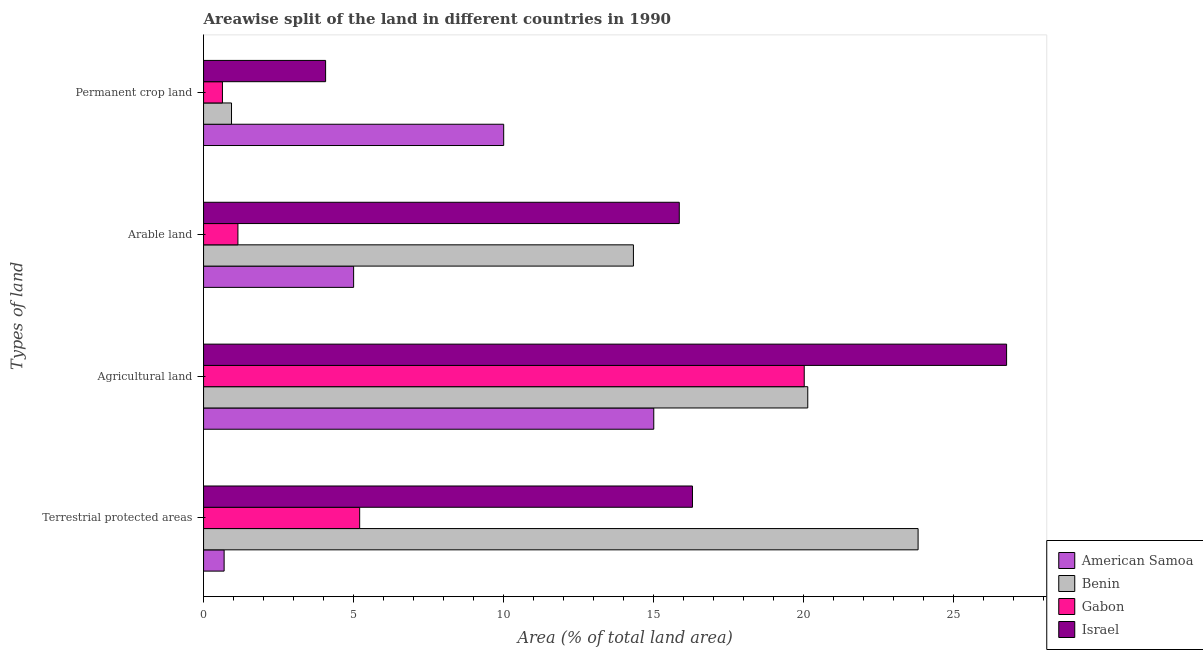How many groups of bars are there?
Your response must be concise. 4. Are the number of bars per tick equal to the number of legend labels?
Your response must be concise. Yes. Are the number of bars on each tick of the Y-axis equal?
Keep it short and to the point. Yes. What is the label of the 1st group of bars from the top?
Provide a short and direct response. Permanent crop land. What is the percentage of area under arable land in Israel?
Your answer should be very brief. 15.85. Across all countries, what is the maximum percentage of area under agricultural land?
Give a very brief answer. 26.76. Across all countries, what is the minimum percentage of area under arable land?
Your response must be concise. 1.14. In which country was the percentage of area under arable land maximum?
Provide a short and direct response. Israel. In which country was the percentage of land under terrestrial protection minimum?
Provide a succinct answer. American Samoa. What is the total percentage of area under permanent crop land in the graph?
Ensure brevity in your answer.  15.63. What is the difference between the percentage of area under agricultural land in Gabon and that in Benin?
Ensure brevity in your answer.  -0.12. What is the difference between the percentage of area under arable land in Benin and the percentage of land under terrestrial protection in Gabon?
Your answer should be compact. 9.12. What is the average percentage of land under terrestrial protection per country?
Offer a terse response. 11.5. What is the difference between the percentage of area under agricultural land and percentage of area under arable land in American Samoa?
Your answer should be very brief. 10. In how many countries, is the percentage of area under agricultural land greater than 6 %?
Your answer should be very brief. 4. What is the ratio of the percentage of area under arable land in Israel to that in Gabon?
Offer a terse response. 13.84. Is the difference between the percentage of land under terrestrial protection in Benin and American Samoa greater than the difference between the percentage of area under permanent crop land in Benin and American Samoa?
Make the answer very short. Yes. What is the difference between the highest and the second highest percentage of area under agricultural land?
Provide a succinct answer. 6.62. What is the difference between the highest and the lowest percentage of area under agricultural land?
Provide a short and direct response. 11.76. Is it the case that in every country, the sum of the percentage of land under terrestrial protection and percentage of area under permanent crop land is greater than the sum of percentage of area under agricultural land and percentage of area under arable land?
Provide a succinct answer. No. What does the 3rd bar from the top in Agricultural land represents?
Provide a short and direct response. Benin. What does the 1st bar from the bottom in Agricultural land represents?
Your response must be concise. American Samoa. Is it the case that in every country, the sum of the percentage of land under terrestrial protection and percentage of area under agricultural land is greater than the percentage of area under arable land?
Give a very brief answer. Yes. Are the values on the major ticks of X-axis written in scientific E-notation?
Give a very brief answer. No. Where does the legend appear in the graph?
Provide a succinct answer. Bottom right. How many legend labels are there?
Provide a succinct answer. 4. What is the title of the graph?
Your answer should be compact. Areawise split of the land in different countries in 1990. Does "East Asia (developing only)" appear as one of the legend labels in the graph?
Make the answer very short. No. What is the label or title of the X-axis?
Offer a terse response. Area (% of total land area). What is the label or title of the Y-axis?
Provide a succinct answer. Types of land. What is the Area (% of total land area) of American Samoa in Terrestrial protected areas?
Your answer should be compact. 0.69. What is the Area (% of total land area) in Benin in Terrestrial protected areas?
Keep it short and to the point. 23.81. What is the Area (% of total land area) of Gabon in Terrestrial protected areas?
Make the answer very short. 5.2. What is the Area (% of total land area) of Israel in Terrestrial protected areas?
Provide a short and direct response. 16.29. What is the Area (% of total land area) in Benin in Agricultural land?
Keep it short and to the point. 20.13. What is the Area (% of total land area) in Gabon in Agricultural land?
Give a very brief answer. 20.01. What is the Area (% of total land area) in Israel in Agricultural land?
Make the answer very short. 26.76. What is the Area (% of total land area) of American Samoa in Arable land?
Keep it short and to the point. 5. What is the Area (% of total land area) in Benin in Arable land?
Keep it short and to the point. 14.32. What is the Area (% of total land area) in Gabon in Arable land?
Ensure brevity in your answer.  1.14. What is the Area (% of total land area) of Israel in Arable land?
Your answer should be very brief. 15.85. What is the Area (% of total land area) of American Samoa in Permanent crop land?
Your answer should be compact. 10. What is the Area (% of total land area) in Benin in Permanent crop land?
Offer a terse response. 0.93. What is the Area (% of total land area) of Gabon in Permanent crop land?
Give a very brief answer. 0.63. What is the Area (% of total land area) in Israel in Permanent crop land?
Your response must be concise. 4.07. Across all Types of land, what is the maximum Area (% of total land area) of American Samoa?
Your response must be concise. 15. Across all Types of land, what is the maximum Area (% of total land area) in Benin?
Offer a terse response. 23.81. Across all Types of land, what is the maximum Area (% of total land area) of Gabon?
Make the answer very short. 20.01. Across all Types of land, what is the maximum Area (% of total land area) of Israel?
Provide a succinct answer. 26.76. Across all Types of land, what is the minimum Area (% of total land area) of American Samoa?
Your response must be concise. 0.69. Across all Types of land, what is the minimum Area (% of total land area) in Benin?
Offer a very short reply. 0.93. Across all Types of land, what is the minimum Area (% of total land area) in Gabon?
Provide a succinct answer. 0.63. Across all Types of land, what is the minimum Area (% of total land area) in Israel?
Your answer should be compact. 4.07. What is the total Area (% of total land area) in American Samoa in the graph?
Your answer should be compact. 30.69. What is the total Area (% of total land area) in Benin in the graph?
Your answer should be compact. 59.19. What is the total Area (% of total land area) in Gabon in the graph?
Your response must be concise. 26.99. What is the total Area (% of total land area) of Israel in the graph?
Provide a short and direct response. 62.96. What is the difference between the Area (% of total land area) of American Samoa in Terrestrial protected areas and that in Agricultural land?
Offer a very short reply. -14.31. What is the difference between the Area (% of total land area) in Benin in Terrestrial protected areas and that in Agricultural land?
Keep it short and to the point. 3.68. What is the difference between the Area (% of total land area) of Gabon in Terrestrial protected areas and that in Agricultural land?
Provide a short and direct response. -14.81. What is the difference between the Area (% of total land area) in Israel in Terrestrial protected areas and that in Agricultural land?
Provide a succinct answer. -10.47. What is the difference between the Area (% of total land area) of American Samoa in Terrestrial protected areas and that in Arable land?
Offer a very short reply. -4.31. What is the difference between the Area (% of total land area) in Benin in Terrestrial protected areas and that in Arable land?
Your answer should be compact. 9.48. What is the difference between the Area (% of total land area) of Gabon in Terrestrial protected areas and that in Arable land?
Give a very brief answer. 4.06. What is the difference between the Area (% of total land area) in Israel in Terrestrial protected areas and that in Arable land?
Provide a short and direct response. 0.44. What is the difference between the Area (% of total land area) in American Samoa in Terrestrial protected areas and that in Permanent crop land?
Make the answer very short. -9.31. What is the difference between the Area (% of total land area) in Benin in Terrestrial protected areas and that in Permanent crop land?
Make the answer very short. 22.88. What is the difference between the Area (% of total land area) of Gabon in Terrestrial protected areas and that in Permanent crop land?
Provide a succinct answer. 4.57. What is the difference between the Area (% of total land area) of Israel in Terrestrial protected areas and that in Permanent crop land?
Keep it short and to the point. 12.22. What is the difference between the Area (% of total land area) in Benin in Agricultural land and that in Arable land?
Ensure brevity in your answer.  5.81. What is the difference between the Area (% of total land area) of Gabon in Agricultural land and that in Arable land?
Give a very brief answer. 18.87. What is the difference between the Area (% of total land area) in Israel in Agricultural land and that in Arable land?
Provide a succinct answer. 10.91. What is the difference between the Area (% of total land area) in American Samoa in Agricultural land and that in Permanent crop land?
Offer a very short reply. 5. What is the difference between the Area (% of total land area) in Benin in Agricultural land and that in Permanent crop land?
Your answer should be very brief. 19.2. What is the difference between the Area (% of total land area) in Gabon in Agricultural land and that in Permanent crop land?
Give a very brief answer. 19.39. What is the difference between the Area (% of total land area) of Israel in Agricultural land and that in Permanent crop land?
Ensure brevity in your answer.  22.69. What is the difference between the Area (% of total land area) in American Samoa in Arable land and that in Permanent crop land?
Your answer should be very brief. -5. What is the difference between the Area (% of total land area) in Benin in Arable land and that in Permanent crop land?
Make the answer very short. 13.39. What is the difference between the Area (% of total land area) in Gabon in Arable land and that in Permanent crop land?
Make the answer very short. 0.52. What is the difference between the Area (% of total land area) of Israel in Arable land and that in Permanent crop land?
Ensure brevity in your answer.  11.78. What is the difference between the Area (% of total land area) of American Samoa in Terrestrial protected areas and the Area (% of total land area) of Benin in Agricultural land?
Your answer should be very brief. -19.45. What is the difference between the Area (% of total land area) in American Samoa in Terrestrial protected areas and the Area (% of total land area) in Gabon in Agricultural land?
Keep it short and to the point. -19.33. What is the difference between the Area (% of total land area) in American Samoa in Terrestrial protected areas and the Area (% of total land area) in Israel in Agricultural land?
Your response must be concise. -26.07. What is the difference between the Area (% of total land area) in Benin in Terrestrial protected areas and the Area (% of total land area) in Gabon in Agricultural land?
Your response must be concise. 3.79. What is the difference between the Area (% of total land area) in Benin in Terrestrial protected areas and the Area (% of total land area) in Israel in Agricultural land?
Your answer should be very brief. -2.95. What is the difference between the Area (% of total land area) in Gabon in Terrestrial protected areas and the Area (% of total land area) in Israel in Agricultural land?
Ensure brevity in your answer.  -21.55. What is the difference between the Area (% of total land area) in American Samoa in Terrestrial protected areas and the Area (% of total land area) in Benin in Arable land?
Keep it short and to the point. -13.64. What is the difference between the Area (% of total land area) of American Samoa in Terrestrial protected areas and the Area (% of total land area) of Gabon in Arable land?
Give a very brief answer. -0.46. What is the difference between the Area (% of total land area) in American Samoa in Terrestrial protected areas and the Area (% of total land area) in Israel in Arable land?
Offer a terse response. -15.16. What is the difference between the Area (% of total land area) of Benin in Terrestrial protected areas and the Area (% of total land area) of Gabon in Arable land?
Ensure brevity in your answer.  22.66. What is the difference between the Area (% of total land area) of Benin in Terrestrial protected areas and the Area (% of total land area) of Israel in Arable land?
Ensure brevity in your answer.  7.96. What is the difference between the Area (% of total land area) of Gabon in Terrestrial protected areas and the Area (% of total land area) of Israel in Arable land?
Give a very brief answer. -10.65. What is the difference between the Area (% of total land area) in American Samoa in Terrestrial protected areas and the Area (% of total land area) in Benin in Permanent crop land?
Offer a very short reply. -0.25. What is the difference between the Area (% of total land area) in American Samoa in Terrestrial protected areas and the Area (% of total land area) in Gabon in Permanent crop land?
Give a very brief answer. 0.06. What is the difference between the Area (% of total land area) in American Samoa in Terrestrial protected areas and the Area (% of total land area) in Israel in Permanent crop land?
Offer a terse response. -3.38. What is the difference between the Area (% of total land area) in Benin in Terrestrial protected areas and the Area (% of total land area) in Gabon in Permanent crop land?
Offer a terse response. 23.18. What is the difference between the Area (% of total land area) of Benin in Terrestrial protected areas and the Area (% of total land area) of Israel in Permanent crop land?
Your answer should be compact. 19.74. What is the difference between the Area (% of total land area) in Gabon in Terrestrial protected areas and the Area (% of total land area) in Israel in Permanent crop land?
Your answer should be very brief. 1.13. What is the difference between the Area (% of total land area) of American Samoa in Agricultural land and the Area (% of total land area) of Benin in Arable land?
Ensure brevity in your answer.  0.68. What is the difference between the Area (% of total land area) of American Samoa in Agricultural land and the Area (% of total land area) of Gabon in Arable land?
Your response must be concise. 13.86. What is the difference between the Area (% of total land area) in American Samoa in Agricultural land and the Area (% of total land area) in Israel in Arable land?
Offer a terse response. -0.85. What is the difference between the Area (% of total land area) in Benin in Agricultural land and the Area (% of total land area) in Gabon in Arable land?
Provide a short and direct response. 18.99. What is the difference between the Area (% of total land area) of Benin in Agricultural land and the Area (% of total land area) of Israel in Arable land?
Provide a succinct answer. 4.28. What is the difference between the Area (% of total land area) of Gabon in Agricultural land and the Area (% of total land area) of Israel in Arable land?
Offer a terse response. 4.16. What is the difference between the Area (% of total land area) in American Samoa in Agricultural land and the Area (% of total land area) in Benin in Permanent crop land?
Provide a short and direct response. 14.07. What is the difference between the Area (% of total land area) in American Samoa in Agricultural land and the Area (% of total land area) in Gabon in Permanent crop land?
Your answer should be compact. 14.37. What is the difference between the Area (% of total land area) of American Samoa in Agricultural land and the Area (% of total land area) of Israel in Permanent crop land?
Ensure brevity in your answer.  10.93. What is the difference between the Area (% of total land area) of Benin in Agricultural land and the Area (% of total land area) of Gabon in Permanent crop land?
Provide a short and direct response. 19.5. What is the difference between the Area (% of total land area) of Benin in Agricultural land and the Area (% of total land area) of Israel in Permanent crop land?
Keep it short and to the point. 16.06. What is the difference between the Area (% of total land area) in Gabon in Agricultural land and the Area (% of total land area) in Israel in Permanent crop land?
Provide a succinct answer. 15.95. What is the difference between the Area (% of total land area) of American Samoa in Arable land and the Area (% of total land area) of Benin in Permanent crop land?
Keep it short and to the point. 4.07. What is the difference between the Area (% of total land area) of American Samoa in Arable land and the Area (% of total land area) of Gabon in Permanent crop land?
Ensure brevity in your answer.  4.37. What is the difference between the Area (% of total land area) in American Samoa in Arable land and the Area (% of total land area) in Israel in Permanent crop land?
Give a very brief answer. 0.93. What is the difference between the Area (% of total land area) of Benin in Arable land and the Area (% of total land area) of Gabon in Permanent crop land?
Offer a terse response. 13.69. What is the difference between the Area (% of total land area) of Benin in Arable land and the Area (% of total land area) of Israel in Permanent crop land?
Your response must be concise. 10.26. What is the difference between the Area (% of total land area) of Gabon in Arable land and the Area (% of total land area) of Israel in Permanent crop land?
Give a very brief answer. -2.92. What is the average Area (% of total land area) of American Samoa per Types of land?
Your response must be concise. 7.67. What is the average Area (% of total land area) in Benin per Types of land?
Your response must be concise. 14.8. What is the average Area (% of total land area) of Gabon per Types of land?
Keep it short and to the point. 6.75. What is the average Area (% of total land area) in Israel per Types of land?
Your answer should be very brief. 15.74. What is the difference between the Area (% of total land area) of American Samoa and Area (% of total land area) of Benin in Terrestrial protected areas?
Your answer should be very brief. -23.12. What is the difference between the Area (% of total land area) in American Samoa and Area (% of total land area) in Gabon in Terrestrial protected areas?
Your answer should be very brief. -4.52. What is the difference between the Area (% of total land area) of American Samoa and Area (% of total land area) of Israel in Terrestrial protected areas?
Provide a succinct answer. -15.6. What is the difference between the Area (% of total land area) of Benin and Area (% of total land area) of Gabon in Terrestrial protected areas?
Give a very brief answer. 18.61. What is the difference between the Area (% of total land area) in Benin and Area (% of total land area) in Israel in Terrestrial protected areas?
Offer a terse response. 7.52. What is the difference between the Area (% of total land area) of Gabon and Area (% of total land area) of Israel in Terrestrial protected areas?
Give a very brief answer. -11.09. What is the difference between the Area (% of total land area) of American Samoa and Area (% of total land area) of Benin in Agricultural land?
Give a very brief answer. -5.13. What is the difference between the Area (% of total land area) of American Samoa and Area (% of total land area) of Gabon in Agricultural land?
Give a very brief answer. -5.01. What is the difference between the Area (% of total land area) of American Samoa and Area (% of total land area) of Israel in Agricultural land?
Give a very brief answer. -11.76. What is the difference between the Area (% of total land area) of Benin and Area (% of total land area) of Gabon in Agricultural land?
Provide a succinct answer. 0.12. What is the difference between the Area (% of total land area) of Benin and Area (% of total land area) of Israel in Agricultural land?
Your answer should be very brief. -6.62. What is the difference between the Area (% of total land area) of Gabon and Area (% of total land area) of Israel in Agricultural land?
Offer a terse response. -6.74. What is the difference between the Area (% of total land area) in American Samoa and Area (% of total land area) in Benin in Arable land?
Provide a short and direct response. -9.32. What is the difference between the Area (% of total land area) of American Samoa and Area (% of total land area) of Gabon in Arable land?
Make the answer very short. 3.86. What is the difference between the Area (% of total land area) in American Samoa and Area (% of total land area) in Israel in Arable land?
Offer a terse response. -10.85. What is the difference between the Area (% of total land area) in Benin and Area (% of total land area) in Gabon in Arable land?
Make the answer very short. 13.18. What is the difference between the Area (% of total land area) in Benin and Area (% of total land area) in Israel in Arable land?
Give a very brief answer. -1.53. What is the difference between the Area (% of total land area) of Gabon and Area (% of total land area) of Israel in Arable land?
Provide a succinct answer. -14.71. What is the difference between the Area (% of total land area) of American Samoa and Area (% of total land area) of Benin in Permanent crop land?
Ensure brevity in your answer.  9.07. What is the difference between the Area (% of total land area) of American Samoa and Area (% of total land area) of Gabon in Permanent crop land?
Make the answer very short. 9.37. What is the difference between the Area (% of total land area) of American Samoa and Area (% of total land area) of Israel in Permanent crop land?
Provide a short and direct response. 5.93. What is the difference between the Area (% of total land area) in Benin and Area (% of total land area) in Gabon in Permanent crop land?
Your response must be concise. 0.3. What is the difference between the Area (% of total land area) in Benin and Area (% of total land area) in Israel in Permanent crop land?
Provide a short and direct response. -3.14. What is the difference between the Area (% of total land area) of Gabon and Area (% of total land area) of Israel in Permanent crop land?
Ensure brevity in your answer.  -3.44. What is the ratio of the Area (% of total land area) of American Samoa in Terrestrial protected areas to that in Agricultural land?
Give a very brief answer. 0.05. What is the ratio of the Area (% of total land area) of Benin in Terrestrial protected areas to that in Agricultural land?
Offer a very short reply. 1.18. What is the ratio of the Area (% of total land area) in Gabon in Terrestrial protected areas to that in Agricultural land?
Give a very brief answer. 0.26. What is the ratio of the Area (% of total land area) in Israel in Terrestrial protected areas to that in Agricultural land?
Your answer should be compact. 0.61. What is the ratio of the Area (% of total land area) of American Samoa in Terrestrial protected areas to that in Arable land?
Offer a very short reply. 0.14. What is the ratio of the Area (% of total land area) of Benin in Terrestrial protected areas to that in Arable land?
Offer a terse response. 1.66. What is the ratio of the Area (% of total land area) of Gabon in Terrestrial protected areas to that in Arable land?
Your response must be concise. 4.54. What is the ratio of the Area (% of total land area) in Israel in Terrestrial protected areas to that in Arable land?
Offer a very short reply. 1.03. What is the ratio of the Area (% of total land area) of American Samoa in Terrestrial protected areas to that in Permanent crop land?
Your answer should be compact. 0.07. What is the ratio of the Area (% of total land area) in Benin in Terrestrial protected areas to that in Permanent crop land?
Provide a short and direct response. 25.57. What is the ratio of the Area (% of total land area) in Gabon in Terrestrial protected areas to that in Permanent crop land?
Your answer should be very brief. 8.27. What is the ratio of the Area (% of total land area) in Israel in Terrestrial protected areas to that in Permanent crop land?
Your answer should be compact. 4.01. What is the ratio of the Area (% of total land area) in Benin in Agricultural land to that in Arable land?
Provide a succinct answer. 1.41. What is the ratio of the Area (% of total land area) of Gabon in Agricultural land to that in Arable land?
Give a very brief answer. 17.48. What is the ratio of the Area (% of total land area) in Israel in Agricultural land to that in Arable land?
Your answer should be compact. 1.69. What is the ratio of the Area (% of total land area) in Benin in Agricultural land to that in Permanent crop land?
Give a very brief answer. 21.62. What is the ratio of the Area (% of total land area) in Gabon in Agricultural land to that in Permanent crop land?
Ensure brevity in your answer.  31.83. What is the ratio of the Area (% of total land area) of Israel in Agricultural land to that in Permanent crop land?
Ensure brevity in your answer.  6.58. What is the ratio of the Area (% of total land area) in Benin in Arable land to that in Permanent crop land?
Keep it short and to the point. 15.38. What is the ratio of the Area (% of total land area) of Gabon in Arable land to that in Permanent crop land?
Offer a terse response. 1.82. What is the ratio of the Area (% of total land area) of Israel in Arable land to that in Permanent crop land?
Provide a succinct answer. 3.9. What is the difference between the highest and the second highest Area (% of total land area) of American Samoa?
Offer a very short reply. 5. What is the difference between the highest and the second highest Area (% of total land area) in Benin?
Provide a short and direct response. 3.68. What is the difference between the highest and the second highest Area (% of total land area) of Gabon?
Give a very brief answer. 14.81. What is the difference between the highest and the second highest Area (% of total land area) in Israel?
Ensure brevity in your answer.  10.47. What is the difference between the highest and the lowest Area (% of total land area) in American Samoa?
Your answer should be compact. 14.31. What is the difference between the highest and the lowest Area (% of total land area) in Benin?
Your answer should be compact. 22.88. What is the difference between the highest and the lowest Area (% of total land area) in Gabon?
Offer a very short reply. 19.39. What is the difference between the highest and the lowest Area (% of total land area) in Israel?
Provide a short and direct response. 22.69. 